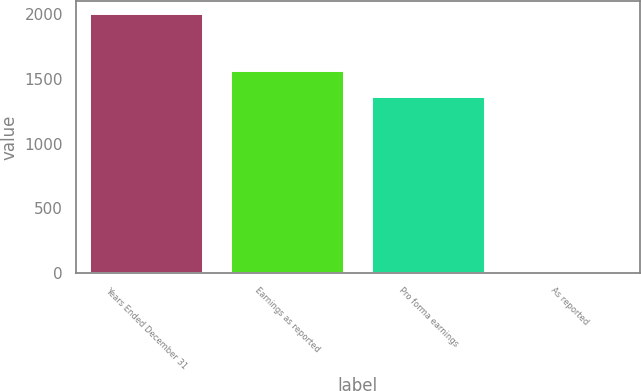Convert chart to OTSL. <chart><loc_0><loc_0><loc_500><loc_500><bar_chart><fcel>Years Ended December 31<fcel>Earnings as reported<fcel>Pro forma earnings<fcel>As reported<nl><fcel>2004<fcel>1563.34<fcel>1363<fcel>0.65<nl></chart> 